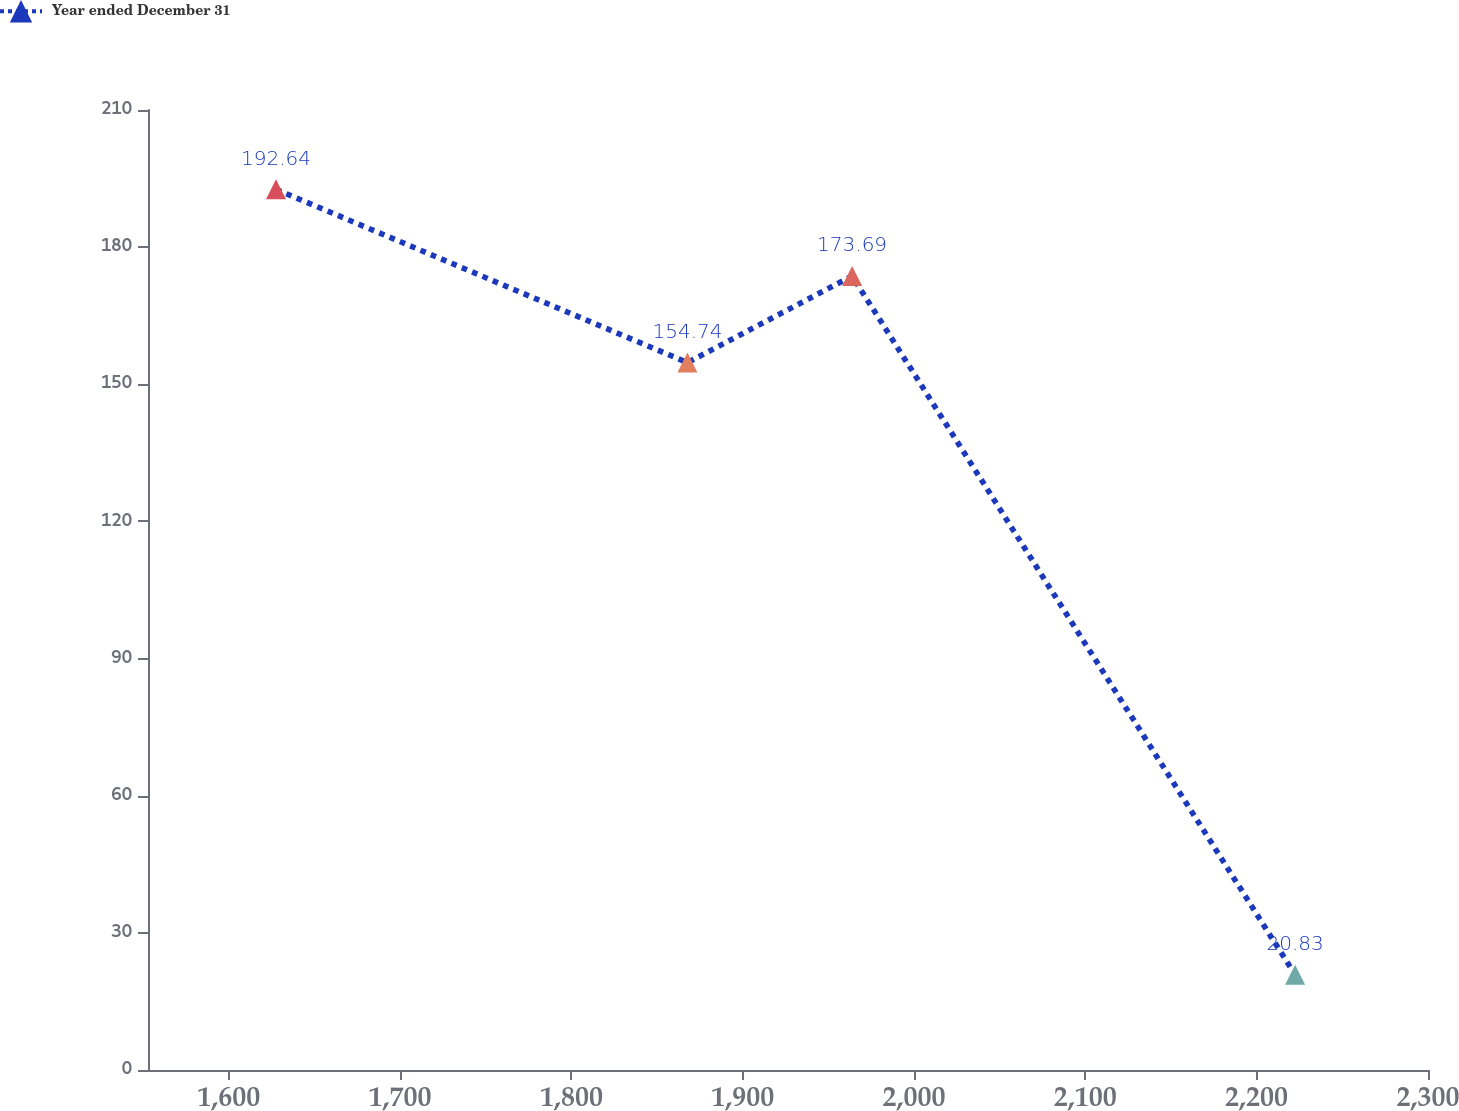<chart> <loc_0><loc_0><loc_500><loc_500><line_chart><ecel><fcel>Year ended December 31<nl><fcel>1627.56<fcel>192.64<nl><fcel>1867.75<fcel>154.74<nl><fcel>1963.86<fcel>173.69<nl><fcel>2222.5<fcel>20.83<nl><fcel>2374.77<fcel>1.88<nl></chart> 